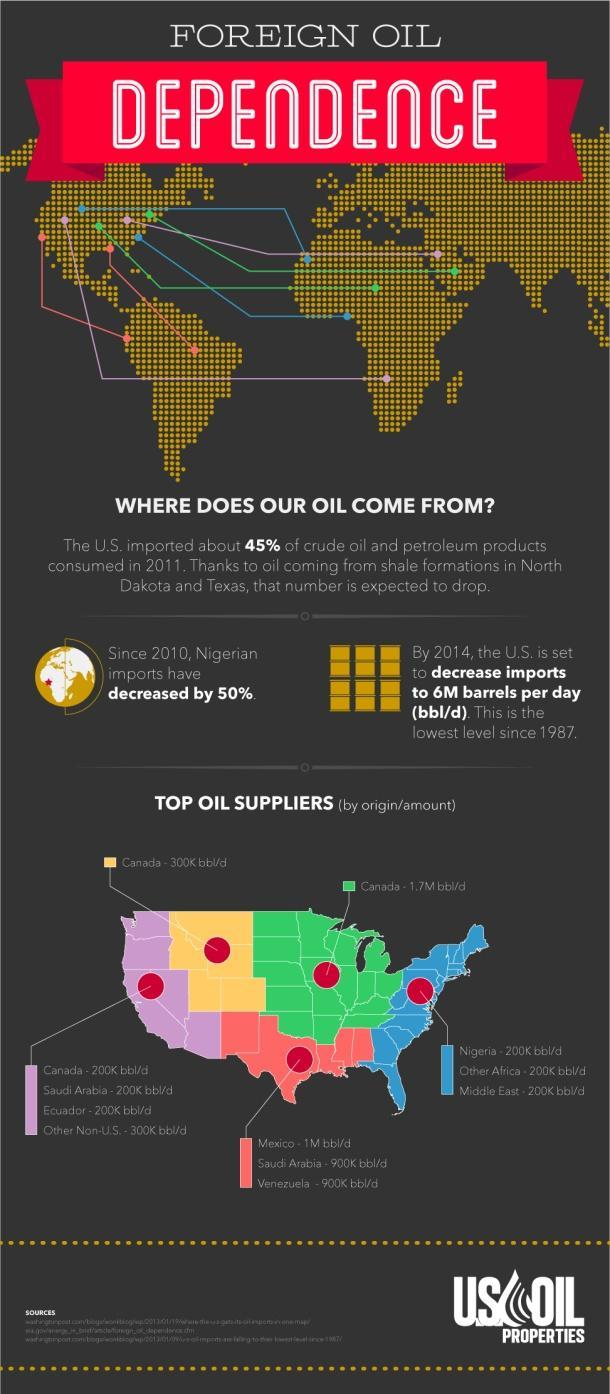What is the color code given to the state which is the biggest oil supplier- red, blue, green, yellow?
Answer the question with a short phrase. green What is the color code given to the state which is the third-biggest oil supplier- red, yellow, green, blue? yellow 